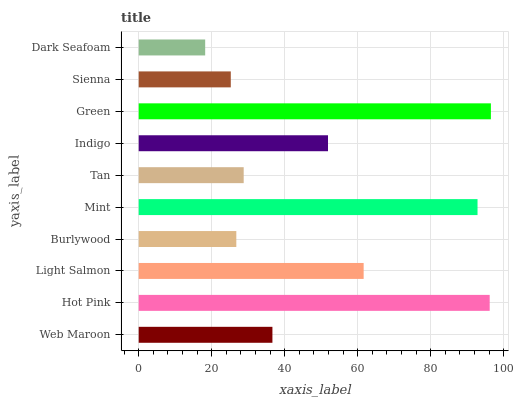Is Dark Seafoam the minimum?
Answer yes or no. Yes. Is Green the maximum?
Answer yes or no. Yes. Is Hot Pink the minimum?
Answer yes or no. No. Is Hot Pink the maximum?
Answer yes or no. No. Is Hot Pink greater than Web Maroon?
Answer yes or no. Yes. Is Web Maroon less than Hot Pink?
Answer yes or no. Yes. Is Web Maroon greater than Hot Pink?
Answer yes or no. No. Is Hot Pink less than Web Maroon?
Answer yes or no. No. Is Indigo the high median?
Answer yes or no. Yes. Is Web Maroon the low median?
Answer yes or no. Yes. Is Web Maroon the high median?
Answer yes or no. No. Is Indigo the low median?
Answer yes or no. No. 